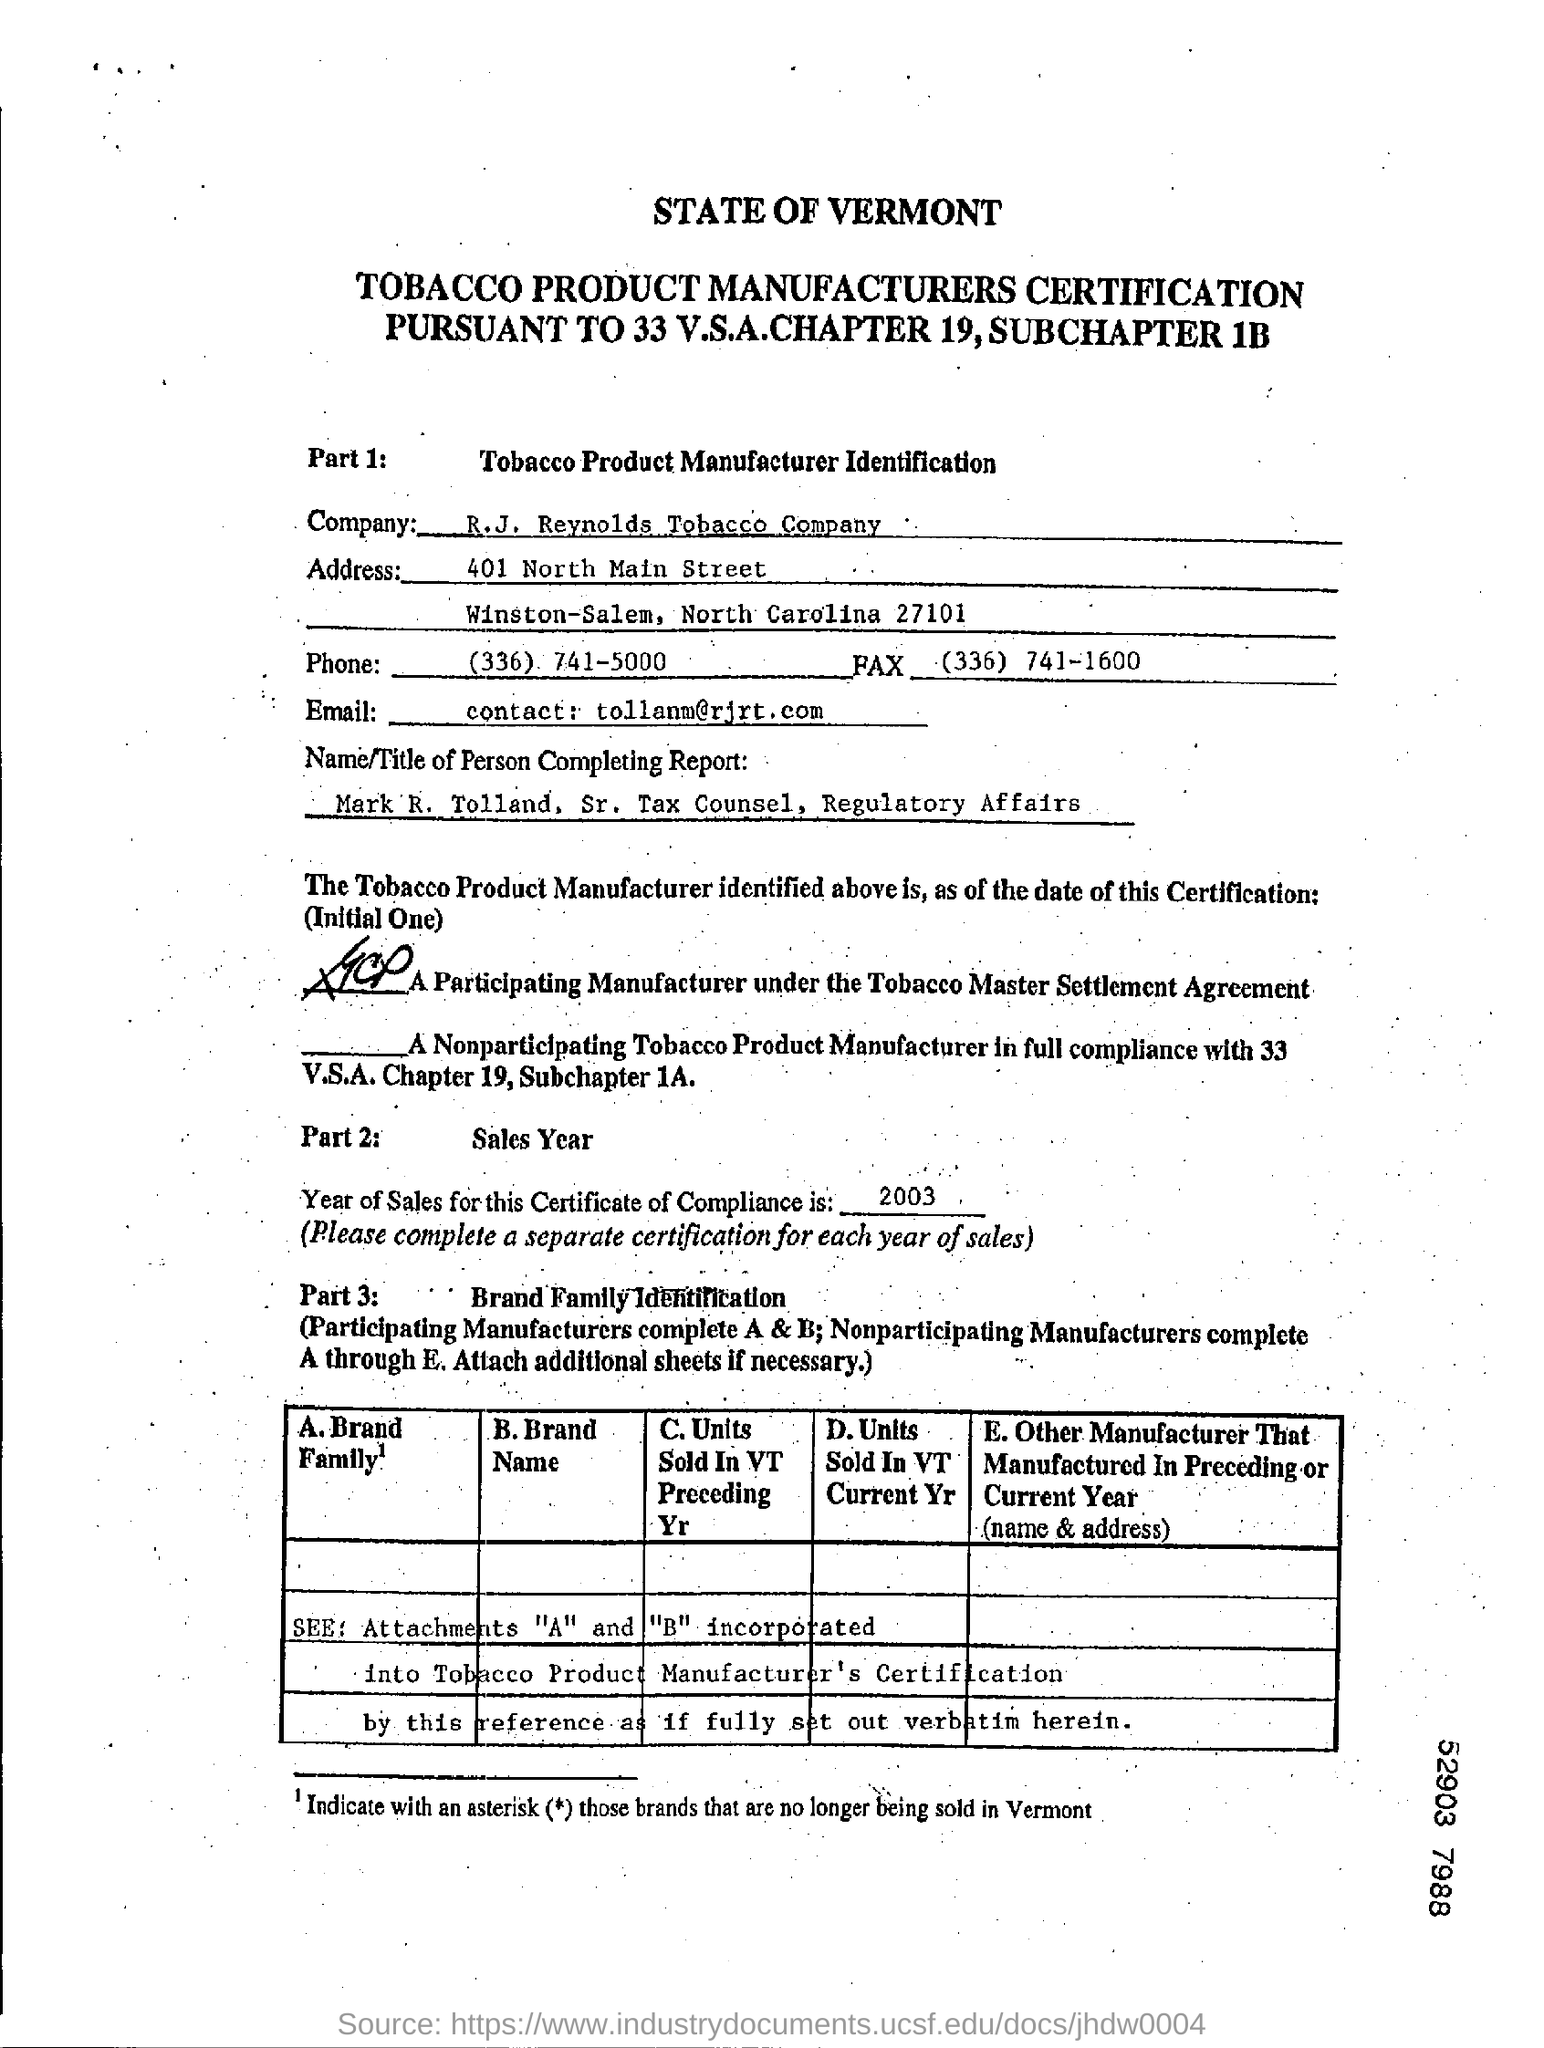List a handful of essential elements in this visual. The person completing the report is Sr. Tax Counsel. R.J. Reynolds Tobacco Company has been certified as a manufacturer of tobacco products. The year for the Certificate of Compliance is 2003. The fax number of the company is (336)741-1600. 